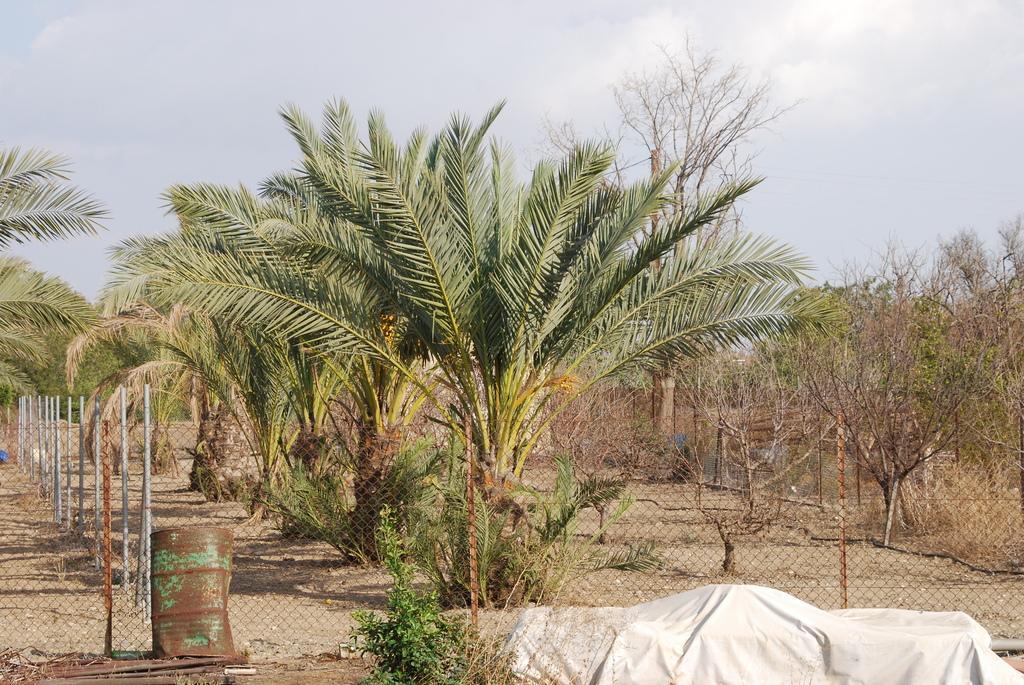Describe this image in one or two sentences. In the image in the center we can see trees,fence,barrel,white color blanket,plants etc. In the background we can see sky and clouds. 